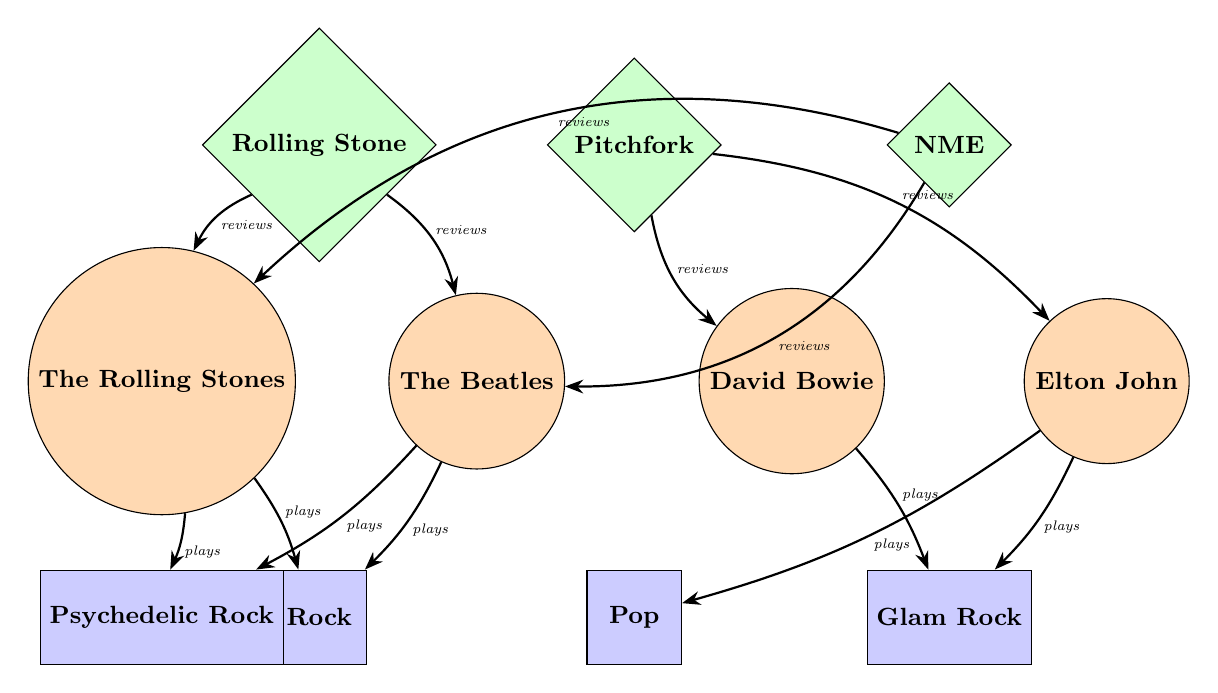What artists are connected to Rock? The diagram shows that The Rolling Stones and The Beatles are both connected to the genre Rock. By following the edges from the genre node labeled Rock, we can see which artists are linked to it.
Answer: The Rolling Stones, The Beatles How many genres are depicted in the diagram? By counting the genre nodes in the diagram, we can identify that there are four genres displayed: Rock, Pop, Glam Rock, and Psychedelic Rock. Thus, the total is determined by simple counting.
Answer: 4 Which critic reviews David Bowie? The diagram shows that David Bowie is reviewed by Pitchfork. By tracing the edges connected to the artist node for David Bowie, we identify the critic linked to him.
Answer: Pitchfork What is the connection type between The Beatles and the genre Psychedelic Rock? The diagram indicates that The Beatles have a connection labeled "plays" to Psychedelic Rock. By examining the edges connecting the artists to the genres, we determine the nature of that relationship.
Answer: plays Which critic has connections to both The Rolling Stones and The Beatles? By examining the connections from the critic nodes to the artist nodes, we find that Rolling Stone reviews both The Rolling Stones and The Beatles. So, we look for a common connection from the critics to the artists.
Answer: Rolling Stone How many artists are reviewed by NME? The diagram shows that NME is connected to The Rolling Stones and The Beatles. By counting the edges extending from the critic node NME, we can determine the number of artists it reviews.
Answer: 2 What genre is connected to Elton John? Elton John is connected to the genres Pop and Glam Rock. By looking at the edges extending from the Elton John node, we see which genres he is linked to.
Answer: Pop, Glam Rock Which artist is exclusively linked to Glam Rock? The diagram indicates that David Bowie is the only artist exclusively linked to Glam Rock, as that artist node does not connect to any other genre besides Glam Rock.
Answer: David Bowie 